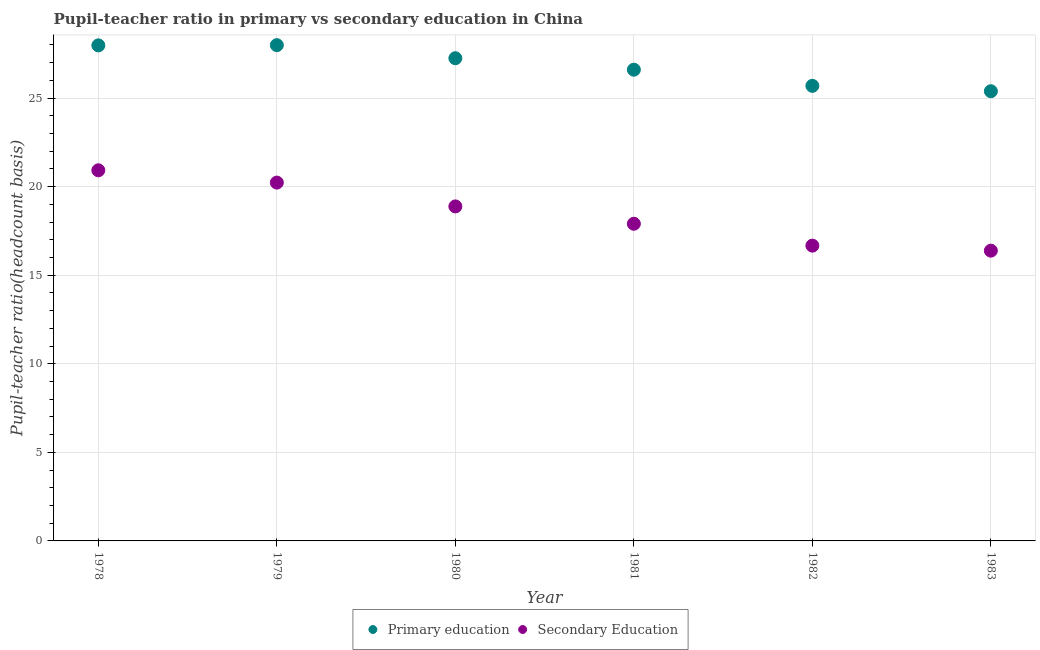How many different coloured dotlines are there?
Keep it short and to the point. 2. Is the number of dotlines equal to the number of legend labels?
Give a very brief answer. Yes. What is the pupil-teacher ratio in primary education in 1978?
Offer a very short reply. 27.97. Across all years, what is the maximum pupil-teacher ratio in primary education?
Offer a very short reply. 27.98. Across all years, what is the minimum pupil-teacher ratio in primary education?
Your response must be concise. 25.38. In which year was the pupil teacher ratio on secondary education maximum?
Provide a succinct answer. 1978. What is the total pupil-teacher ratio in primary education in the graph?
Give a very brief answer. 160.86. What is the difference between the pupil teacher ratio on secondary education in 1980 and that in 1982?
Make the answer very short. 2.21. What is the difference between the pupil-teacher ratio in primary education in 1981 and the pupil teacher ratio on secondary education in 1983?
Provide a succinct answer. 10.21. What is the average pupil teacher ratio on secondary education per year?
Provide a succinct answer. 18.5. In the year 1980, what is the difference between the pupil-teacher ratio in primary education and pupil teacher ratio on secondary education?
Your answer should be compact. 8.36. What is the ratio of the pupil teacher ratio on secondary education in 1978 to that in 1983?
Provide a short and direct response. 1.28. Is the difference between the pupil teacher ratio on secondary education in 1980 and 1982 greater than the difference between the pupil-teacher ratio in primary education in 1980 and 1982?
Offer a very short reply. Yes. What is the difference between the highest and the second highest pupil teacher ratio on secondary education?
Offer a terse response. 0.69. What is the difference between the highest and the lowest pupil teacher ratio on secondary education?
Make the answer very short. 4.54. Is the sum of the pupil teacher ratio on secondary education in 1978 and 1980 greater than the maximum pupil-teacher ratio in primary education across all years?
Your response must be concise. Yes. Is the pupil-teacher ratio in primary education strictly less than the pupil teacher ratio on secondary education over the years?
Make the answer very short. No. How many dotlines are there?
Offer a very short reply. 2. How many years are there in the graph?
Make the answer very short. 6. Where does the legend appear in the graph?
Make the answer very short. Bottom center. How are the legend labels stacked?
Your answer should be very brief. Horizontal. What is the title of the graph?
Make the answer very short. Pupil-teacher ratio in primary vs secondary education in China. What is the label or title of the X-axis?
Ensure brevity in your answer.  Year. What is the label or title of the Y-axis?
Your answer should be very brief. Pupil-teacher ratio(headcount basis). What is the Pupil-teacher ratio(headcount basis) in Primary education in 1978?
Offer a terse response. 27.97. What is the Pupil-teacher ratio(headcount basis) in Secondary Education in 1978?
Offer a very short reply. 20.92. What is the Pupil-teacher ratio(headcount basis) in Primary education in 1979?
Give a very brief answer. 27.98. What is the Pupil-teacher ratio(headcount basis) of Secondary Education in 1979?
Provide a succinct answer. 20.23. What is the Pupil-teacher ratio(headcount basis) in Primary education in 1980?
Keep it short and to the point. 27.25. What is the Pupil-teacher ratio(headcount basis) in Secondary Education in 1980?
Your response must be concise. 18.88. What is the Pupil-teacher ratio(headcount basis) of Primary education in 1981?
Provide a succinct answer. 26.6. What is the Pupil-teacher ratio(headcount basis) in Secondary Education in 1981?
Give a very brief answer. 17.9. What is the Pupil-teacher ratio(headcount basis) of Primary education in 1982?
Provide a succinct answer. 25.69. What is the Pupil-teacher ratio(headcount basis) of Secondary Education in 1982?
Offer a very short reply. 16.67. What is the Pupil-teacher ratio(headcount basis) in Primary education in 1983?
Give a very brief answer. 25.38. What is the Pupil-teacher ratio(headcount basis) in Secondary Education in 1983?
Provide a short and direct response. 16.38. Across all years, what is the maximum Pupil-teacher ratio(headcount basis) of Primary education?
Your answer should be compact. 27.98. Across all years, what is the maximum Pupil-teacher ratio(headcount basis) in Secondary Education?
Your answer should be very brief. 20.92. Across all years, what is the minimum Pupil-teacher ratio(headcount basis) of Primary education?
Offer a terse response. 25.38. Across all years, what is the minimum Pupil-teacher ratio(headcount basis) of Secondary Education?
Provide a succinct answer. 16.38. What is the total Pupil-teacher ratio(headcount basis) of Primary education in the graph?
Provide a short and direct response. 160.87. What is the total Pupil-teacher ratio(headcount basis) in Secondary Education in the graph?
Your answer should be very brief. 110.98. What is the difference between the Pupil-teacher ratio(headcount basis) in Primary education in 1978 and that in 1979?
Offer a terse response. -0.01. What is the difference between the Pupil-teacher ratio(headcount basis) in Secondary Education in 1978 and that in 1979?
Offer a terse response. 0.69. What is the difference between the Pupil-teacher ratio(headcount basis) in Primary education in 1978 and that in 1980?
Your answer should be very brief. 0.73. What is the difference between the Pupil-teacher ratio(headcount basis) of Secondary Education in 1978 and that in 1980?
Provide a short and direct response. 2.04. What is the difference between the Pupil-teacher ratio(headcount basis) of Primary education in 1978 and that in 1981?
Give a very brief answer. 1.37. What is the difference between the Pupil-teacher ratio(headcount basis) in Secondary Education in 1978 and that in 1981?
Your response must be concise. 3.02. What is the difference between the Pupil-teacher ratio(headcount basis) in Primary education in 1978 and that in 1982?
Ensure brevity in your answer.  2.29. What is the difference between the Pupil-teacher ratio(headcount basis) of Secondary Education in 1978 and that in 1982?
Ensure brevity in your answer.  4.25. What is the difference between the Pupil-teacher ratio(headcount basis) in Primary education in 1978 and that in 1983?
Your response must be concise. 2.59. What is the difference between the Pupil-teacher ratio(headcount basis) in Secondary Education in 1978 and that in 1983?
Offer a very short reply. 4.54. What is the difference between the Pupil-teacher ratio(headcount basis) in Primary education in 1979 and that in 1980?
Your response must be concise. 0.74. What is the difference between the Pupil-teacher ratio(headcount basis) in Secondary Education in 1979 and that in 1980?
Offer a very short reply. 1.34. What is the difference between the Pupil-teacher ratio(headcount basis) of Primary education in 1979 and that in 1981?
Your response must be concise. 1.39. What is the difference between the Pupil-teacher ratio(headcount basis) in Secondary Education in 1979 and that in 1981?
Provide a short and direct response. 2.32. What is the difference between the Pupil-teacher ratio(headcount basis) in Primary education in 1979 and that in 1982?
Your answer should be very brief. 2.3. What is the difference between the Pupil-teacher ratio(headcount basis) in Secondary Education in 1979 and that in 1982?
Provide a short and direct response. 3.56. What is the difference between the Pupil-teacher ratio(headcount basis) of Primary education in 1979 and that in 1983?
Offer a terse response. 2.6. What is the difference between the Pupil-teacher ratio(headcount basis) in Secondary Education in 1979 and that in 1983?
Your response must be concise. 3.84. What is the difference between the Pupil-teacher ratio(headcount basis) in Primary education in 1980 and that in 1981?
Ensure brevity in your answer.  0.65. What is the difference between the Pupil-teacher ratio(headcount basis) in Secondary Education in 1980 and that in 1981?
Make the answer very short. 0.98. What is the difference between the Pupil-teacher ratio(headcount basis) in Primary education in 1980 and that in 1982?
Your response must be concise. 1.56. What is the difference between the Pupil-teacher ratio(headcount basis) in Secondary Education in 1980 and that in 1982?
Your answer should be compact. 2.21. What is the difference between the Pupil-teacher ratio(headcount basis) in Primary education in 1980 and that in 1983?
Your response must be concise. 1.86. What is the difference between the Pupil-teacher ratio(headcount basis) in Secondary Education in 1980 and that in 1983?
Provide a succinct answer. 2.5. What is the difference between the Pupil-teacher ratio(headcount basis) in Primary education in 1981 and that in 1982?
Your answer should be very brief. 0.91. What is the difference between the Pupil-teacher ratio(headcount basis) of Secondary Education in 1981 and that in 1982?
Provide a succinct answer. 1.24. What is the difference between the Pupil-teacher ratio(headcount basis) of Primary education in 1981 and that in 1983?
Ensure brevity in your answer.  1.22. What is the difference between the Pupil-teacher ratio(headcount basis) in Secondary Education in 1981 and that in 1983?
Ensure brevity in your answer.  1.52. What is the difference between the Pupil-teacher ratio(headcount basis) in Primary education in 1982 and that in 1983?
Offer a very short reply. 0.3. What is the difference between the Pupil-teacher ratio(headcount basis) in Secondary Education in 1982 and that in 1983?
Your response must be concise. 0.28. What is the difference between the Pupil-teacher ratio(headcount basis) in Primary education in 1978 and the Pupil-teacher ratio(headcount basis) in Secondary Education in 1979?
Provide a short and direct response. 7.75. What is the difference between the Pupil-teacher ratio(headcount basis) in Primary education in 1978 and the Pupil-teacher ratio(headcount basis) in Secondary Education in 1980?
Your response must be concise. 9.09. What is the difference between the Pupil-teacher ratio(headcount basis) of Primary education in 1978 and the Pupil-teacher ratio(headcount basis) of Secondary Education in 1981?
Keep it short and to the point. 10.07. What is the difference between the Pupil-teacher ratio(headcount basis) of Primary education in 1978 and the Pupil-teacher ratio(headcount basis) of Secondary Education in 1982?
Your answer should be very brief. 11.3. What is the difference between the Pupil-teacher ratio(headcount basis) in Primary education in 1978 and the Pupil-teacher ratio(headcount basis) in Secondary Education in 1983?
Give a very brief answer. 11.59. What is the difference between the Pupil-teacher ratio(headcount basis) in Primary education in 1979 and the Pupil-teacher ratio(headcount basis) in Secondary Education in 1980?
Offer a very short reply. 9.1. What is the difference between the Pupil-teacher ratio(headcount basis) in Primary education in 1979 and the Pupil-teacher ratio(headcount basis) in Secondary Education in 1981?
Your answer should be compact. 10.08. What is the difference between the Pupil-teacher ratio(headcount basis) in Primary education in 1979 and the Pupil-teacher ratio(headcount basis) in Secondary Education in 1982?
Keep it short and to the point. 11.32. What is the difference between the Pupil-teacher ratio(headcount basis) in Primary education in 1979 and the Pupil-teacher ratio(headcount basis) in Secondary Education in 1983?
Offer a terse response. 11.6. What is the difference between the Pupil-teacher ratio(headcount basis) in Primary education in 1980 and the Pupil-teacher ratio(headcount basis) in Secondary Education in 1981?
Your response must be concise. 9.34. What is the difference between the Pupil-teacher ratio(headcount basis) of Primary education in 1980 and the Pupil-teacher ratio(headcount basis) of Secondary Education in 1982?
Your answer should be compact. 10.58. What is the difference between the Pupil-teacher ratio(headcount basis) of Primary education in 1980 and the Pupil-teacher ratio(headcount basis) of Secondary Education in 1983?
Give a very brief answer. 10.86. What is the difference between the Pupil-teacher ratio(headcount basis) of Primary education in 1981 and the Pupil-teacher ratio(headcount basis) of Secondary Education in 1982?
Provide a succinct answer. 9.93. What is the difference between the Pupil-teacher ratio(headcount basis) in Primary education in 1981 and the Pupil-teacher ratio(headcount basis) in Secondary Education in 1983?
Give a very brief answer. 10.21. What is the difference between the Pupil-teacher ratio(headcount basis) of Primary education in 1982 and the Pupil-teacher ratio(headcount basis) of Secondary Education in 1983?
Ensure brevity in your answer.  9.3. What is the average Pupil-teacher ratio(headcount basis) in Primary education per year?
Keep it short and to the point. 26.81. What is the average Pupil-teacher ratio(headcount basis) of Secondary Education per year?
Your answer should be very brief. 18.5. In the year 1978, what is the difference between the Pupil-teacher ratio(headcount basis) of Primary education and Pupil-teacher ratio(headcount basis) of Secondary Education?
Your answer should be compact. 7.05. In the year 1979, what is the difference between the Pupil-teacher ratio(headcount basis) of Primary education and Pupil-teacher ratio(headcount basis) of Secondary Education?
Ensure brevity in your answer.  7.76. In the year 1980, what is the difference between the Pupil-teacher ratio(headcount basis) of Primary education and Pupil-teacher ratio(headcount basis) of Secondary Education?
Keep it short and to the point. 8.36. In the year 1981, what is the difference between the Pupil-teacher ratio(headcount basis) of Primary education and Pupil-teacher ratio(headcount basis) of Secondary Education?
Provide a short and direct response. 8.7. In the year 1982, what is the difference between the Pupil-teacher ratio(headcount basis) of Primary education and Pupil-teacher ratio(headcount basis) of Secondary Education?
Provide a succinct answer. 9.02. In the year 1983, what is the difference between the Pupil-teacher ratio(headcount basis) of Primary education and Pupil-teacher ratio(headcount basis) of Secondary Education?
Make the answer very short. 9. What is the ratio of the Pupil-teacher ratio(headcount basis) in Primary education in 1978 to that in 1979?
Your response must be concise. 1. What is the ratio of the Pupil-teacher ratio(headcount basis) of Secondary Education in 1978 to that in 1979?
Your answer should be compact. 1.03. What is the ratio of the Pupil-teacher ratio(headcount basis) of Primary education in 1978 to that in 1980?
Keep it short and to the point. 1.03. What is the ratio of the Pupil-teacher ratio(headcount basis) of Secondary Education in 1978 to that in 1980?
Ensure brevity in your answer.  1.11. What is the ratio of the Pupil-teacher ratio(headcount basis) of Primary education in 1978 to that in 1981?
Your answer should be compact. 1.05. What is the ratio of the Pupil-teacher ratio(headcount basis) in Secondary Education in 1978 to that in 1981?
Give a very brief answer. 1.17. What is the ratio of the Pupil-teacher ratio(headcount basis) of Primary education in 1978 to that in 1982?
Provide a succinct answer. 1.09. What is the ratio of the Pupil-teacher ratio(headcount basis) in Secondary Education in 1978 to that in 1982?
Make the answer very short. 1.26. What is the ratio of the Pupil-teacher ratio(headcount basis) of Primary education in 1978 to that in 1983?
Offer a terse response. 1.1. What is the ratio of the Pupil-teacher ratio(headcount basis) of Secondary Education in 1978 to that in 1983?
Provide a short and direct response. 1.28. What is the ratio of the Pupil-teacher ratio(headcount basis) of Primary education in 1979 to that in 1980?
Give a very brief answer. 1.03. What is the ratio of the Pupil-teacher ratio(headcount basis) of Secondary Education in 1979 to that in 1980?
Your answer should be very brief. 1.07. What is the ratio of the Pupil-teacher ratio(headcount basis) in Primary education in 1979 to that in 1981?
Your answer should be very brief. 1.05. What is the ratio of the Pupil-teacher ratio(headcount basis) of Secondary Education in 1979 to that in 1981?
Ensure brevity in your answer.  1.13. What is the ratio of the Pupil-teacher ratio(headcount basis) in Primary education in 1979 to that in 1982?
Ensure brevity in your answer.  1.09. What is the ratio of the Pupil-teacher ratio(headcount basis) in Secondary Education in 1979 to that in 1982?
Your answer should be compact. 1.21. What is the ratio of the Pupil-teacher ratio(headcount basis) in Primary education in 1979 to that in 1983?
Your answer should be very brief. 1.1. What is the ratio of the Pupil-teacher ratio(headcount basis) in Secondary Education in 1979 to that in 1983?
Keep it short and to the point. 1.23. What is the ratio of the Pupil-teacher ratio(headcount basis) of Primary education in 1980 to that in 1981?
Give a very brief answer. 1.02. What is the ratio of the Pupil-teacher ratio(headcount basis) in Secondary Education in 1980 to that in 1981?
Give a very brief answer. 1.05. What is the ratio of the Pupil-teacher ratio(headcount basis) of Primary education in 1980 to that in 1982?
Provide a succinct answer. 1.06. What is the ratio of the Pupil-teacher ratio(headcount basis) in Secondary Education in 1980 to that in 1982?
Provide a succinct answer. 1.13. What is the ratio of the Pupil-teacher ratio(headcount basis) in Primary education in 1980 to that in 1983?
Make the answer very short. 1.07. What is the ratio of the Pupil-teacher ratio(headcount basis) of Secondary Education in 1980 to that in 1983?
Keep it short and to the point. 1.15. What is the ratio of the Pupil-teacher ratio(headcount basis) in Primary education in 1981 to that in 1982?
Provide a succinct answer. 1.04. What is the ratio of the Pupil-teacher ratio(headcount basis) in Secondary Education in 1981 to that in 1982?
Offer a terse response. 1.07. What is the ratio of the Pupil-teacher ratio(headcount basis) in Primary education in 1981 to that in 1983?
Offer a very short reply. 1.05. What is the ratio of the Pupil-teacher ratio(headcount basis) of Secondary Education in 1981 to that in 1983?
Make the answer very short. 1.09. What is the ratio of the Pupil-teacher ratio(headcount basis) in Primary education in 1982 to that in 1983?
Provide a succinct answer. 1.01. What is the ratio of the Pupil-teacher ratio(headcount basis) of Secondary Education in 1982 to that in 1983?
Ensure brevity in your answer.  1.02. What is the difference between the highest and the second highest Pupil-teacher ratio(headcount basis) of Primary education?
Your answer should be very brief. 0.01. What is the difference between the highest and the second highest Pupil-teacher ratio(headcount basis) of Secondary Education?
Keep it short and to the point. 0.69. What is the difference between the highest and the lowest Pupil-teacher ratio(headcount basis) in Primary education?
Ensure brevity in your answer.  2.6. What is the difference between the highest and the lowest Pupil-teacher ratio(headcount basis) in Secondary Education?
Your answer should be very brief. 4.54. 